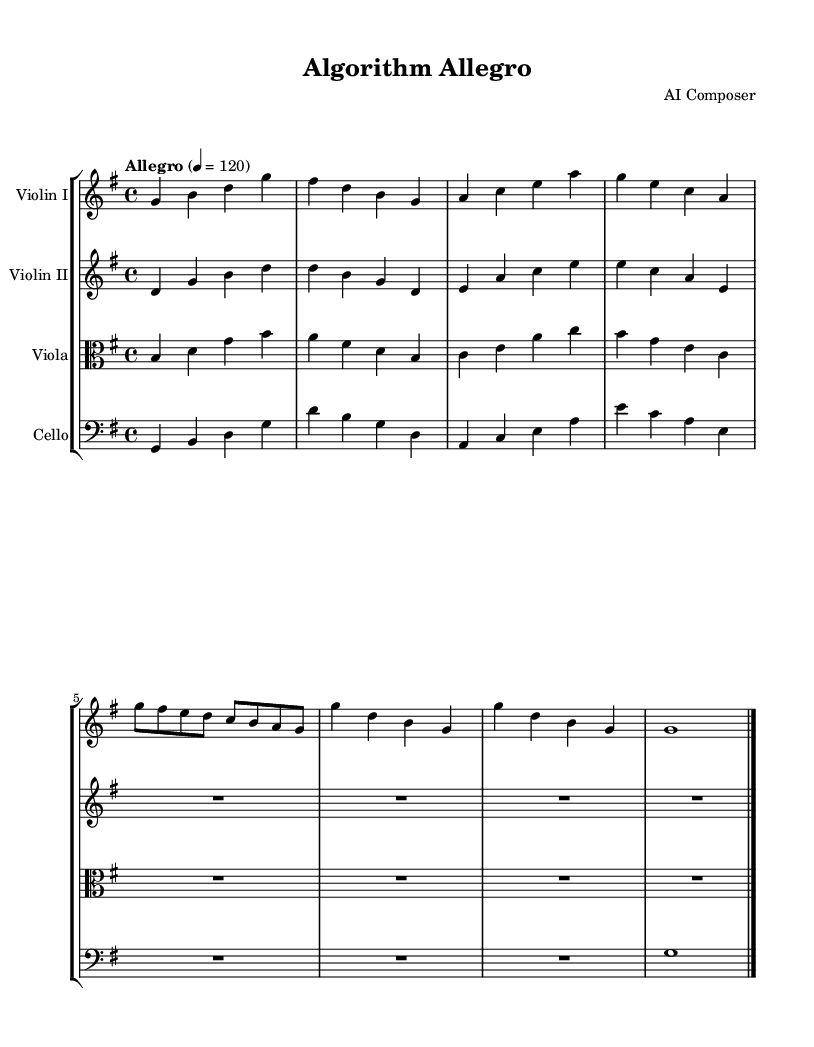What is the key signature of this music? The key signature is indicated at the beginning and shows one sharp, which corresponds to G major.
Answer: G major What is the time signature of the music? The time signature appears right after the key signature and is written as 4 over 4, indicating four beats per measure.
Answer: 4/4 What is the tempo marking of this composition? The tempo marking is indicated above the music and states "Allegro," with a metronome marking of 120 beats per minute.
Answer: Allegro How many measures are in the first violin part? The first violin part has a total of eight measures, which can be counted from the music notation.
Answer: Eight Which instruments are included in the score? The instruments are listed in the staff group at the beginning, named as Violin I, Violin II, Viola, and Cello.
Answer: Violin I, Violin II, Viola, Cello What is the rhythmic pattern of the second violin part in the second half? In the second half of the second violin part, there are rests (notated as R1) for four beats, indicating silence.
Answer: Rests What structural element is commonly found in Baroque chamber music, evident in this composition? The composition exhibits a call-and-response format or dialogue between instruments, a prominent characteristic of Baroque music.
Answer: Dialogue 